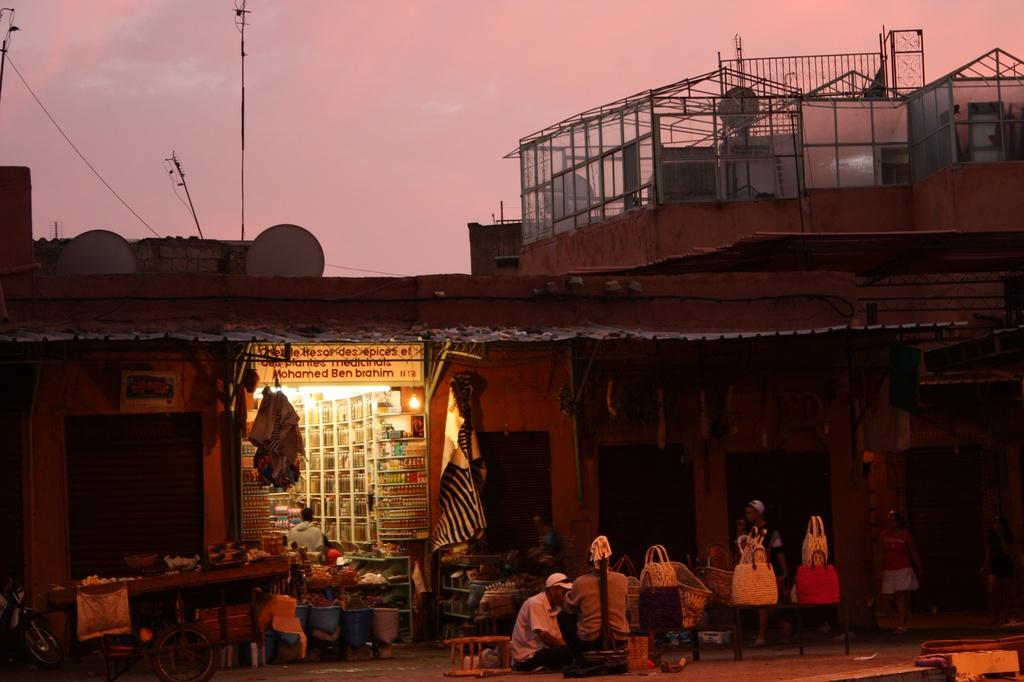What type of establishment is located on the left side of the image? There is a store on the left side of the image. What are the two persons in the image doing? The two persons are sitting in the middle of the image. What structure is located at the top of the image? There is a house at the top of the image. What is visible at the top of the image? The sky is visible at the top of the image. What type of jail can be seen in the image? There is no jail present in the image. What religious symbols are visible in the image? There are no religious symbols visible in the image. 